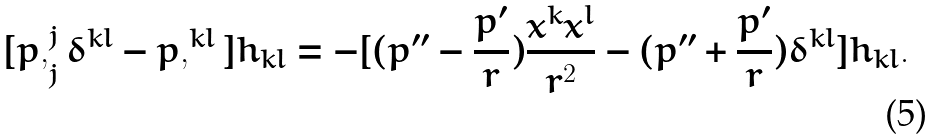<formula> <loc_0><loc_0><loc_500><loc_500>[ p , _ { j } ^ { j } \delta ^ { k l } - p , ^ { k l } ] h _ { k l } = - [ ( p ^ { \prime \prime } - \frac { p ^ { \prime } } { r } ) \frac { x ^ { k } x ^ { l } } { r ^ { 2 } } - ( p ^ { \prime \prime } + \frac { p ^ { \prime } } { r } ) \delta ^ { k l } ] h _ { k l } .</formula> 